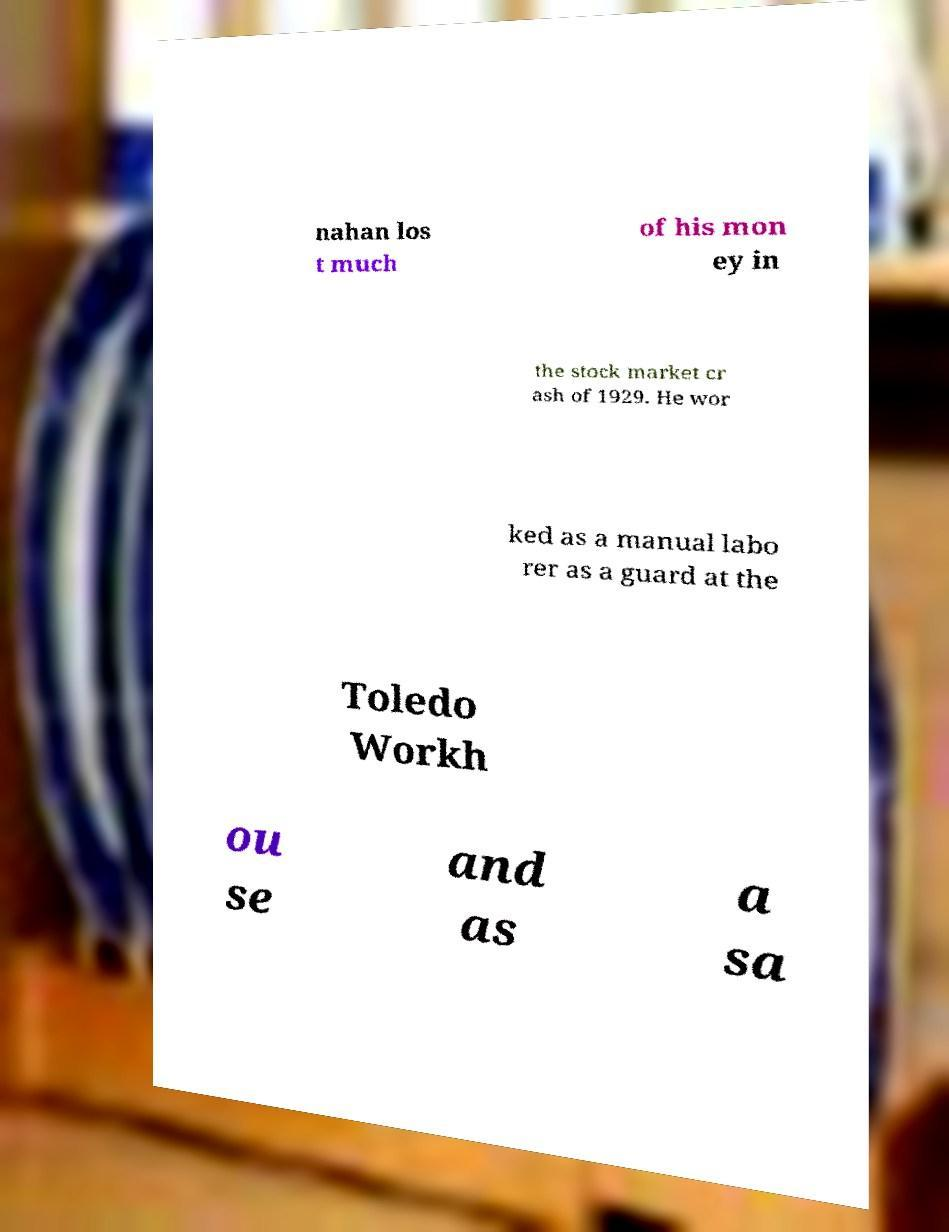There's text embedded in this image that I need extracted. Can you transcribe it verbatim? nahan los t much of his mon ey in the stock market cr ash of 1929. He wor ked as a manual labo rer as a guard at the Toledo Workh ou se and as a sa 